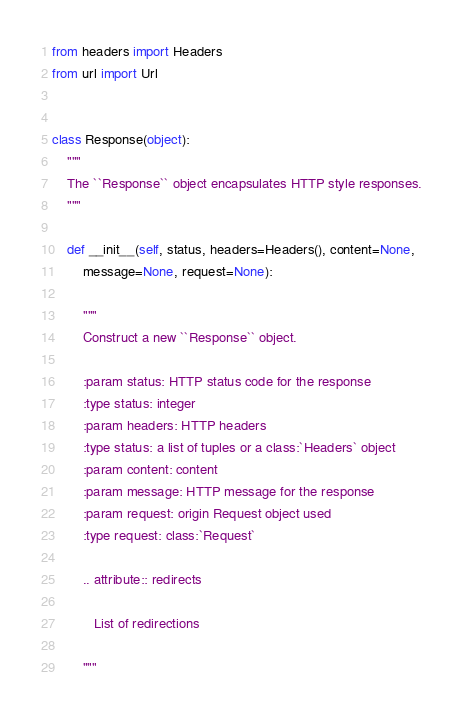<code> <loc_0><loc_0><loc_500><loc_500><_Python_>from headers import Headers
from url import Url


class Response(object):
    """
    The ``Response`` object encapsulates HTTP style responses.
    """

    def __init__(self, status, headers=Headers(), content=None,
        message=None, request=None):

        """
        Construct a new ``Response`` object.

        :param status: HTTP status code for the response
        :type status: integer
        :param headers: HTTP headers
        :type status: a list of tuples or a class:`Headers` object
        :param content: content
        :param message: HTTP message for the response
        :param request: origin Request object used
        :type request: class:`Request`

        .. attribute:: redirects

           List of redirections

        """
</code> 